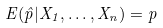<formula> <loc_0><loc_0><loc_500><loc_500>E ( \hat { p } | X _ { 1 } , \dots , X _ { n } ) = p</formula> 